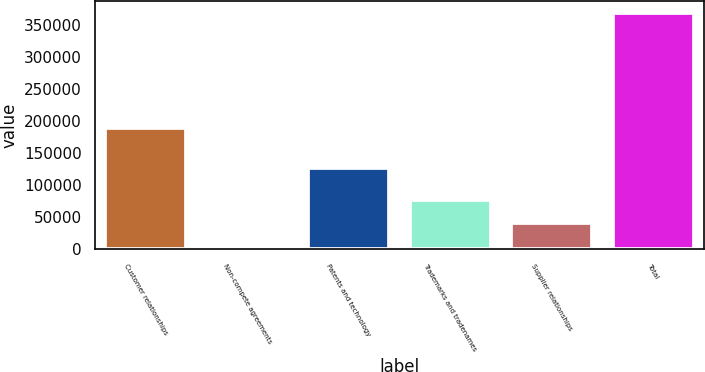<chart> <loc_0><loc_0><loc_500><loc_500><bar_chart><fcel>Customer relationships<fcel>Non-compete agreements<fcel>Patents and technology<fcel>Trademarks and tradenames<fcel>Supplier relationships<fcel>Total<nl><fcel>189752<fcel>3945<fcel>126149<fcel>76904.6<fcel>40424.8<fcel>368743<nl></chart> 